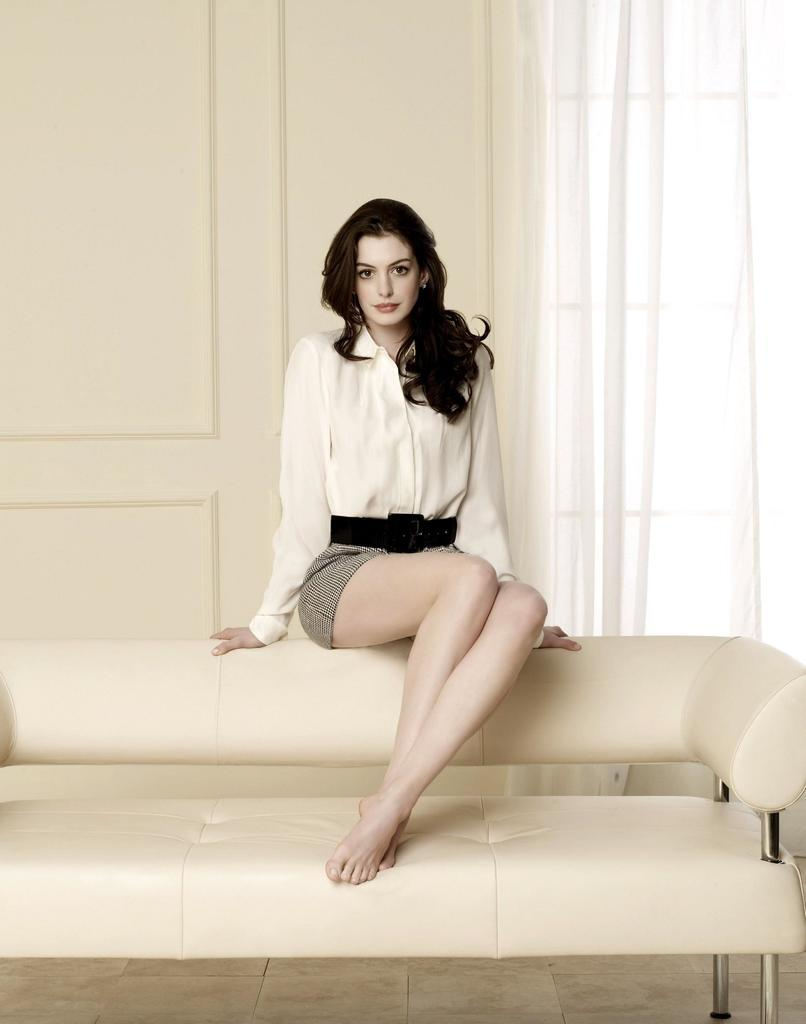Who is present in the image? There is a lady in the picture. What is the lady doing in the image? The lady is sitting on a sofa. What can be seen below the sofa in the image? There is a ground visible in the image. What is on the wall behind the sofa? There is a wall with a curtain in the image. What type of rifle is the lady holding in the image? There is no rifle present in the image; the lady is sitting on a sofa. What cut of beef can be seen on the plate next to the lady? There is no plate or beef present in the image; only the lady, sofa, ground, and wall with a curtain are visible. 